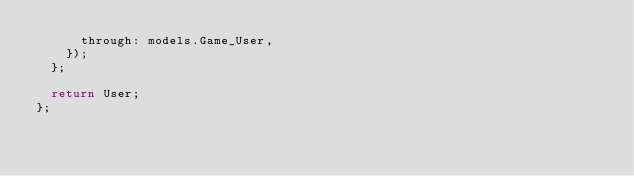Convert code to text. <code><loc_0><loc_0><loc_500><loc_500><_JavaScript_>      through: models.Game_User,
    });
  };

  return User;
};
</code> 